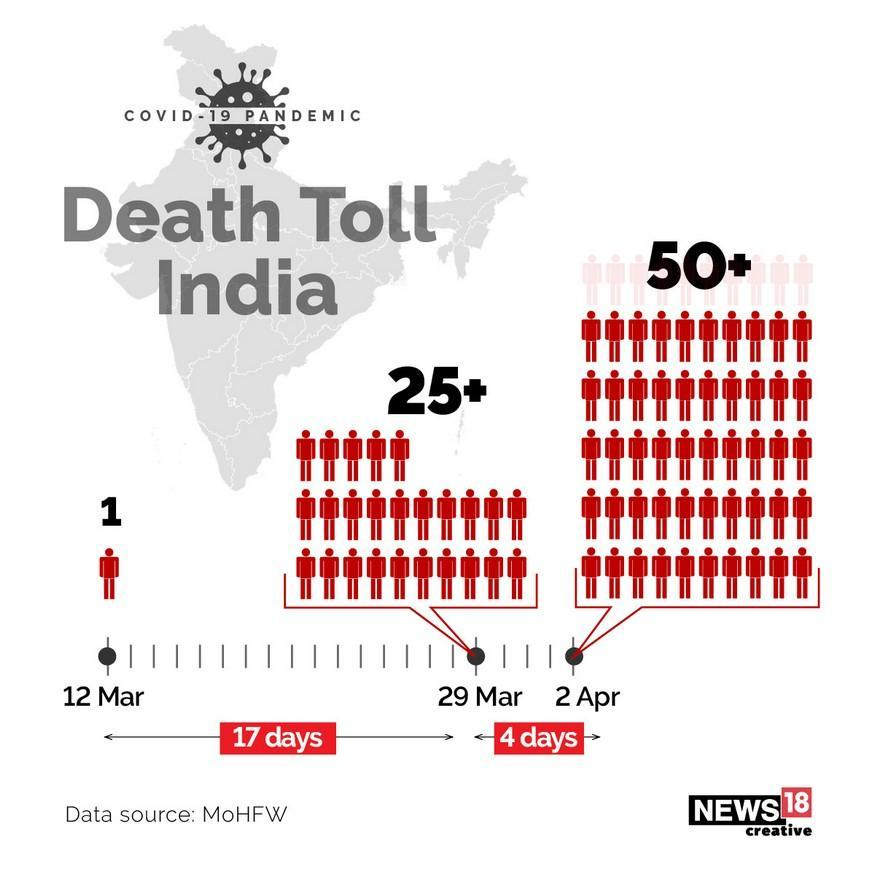What is the difference between 29th march and 12th march?
Answer the question with a short phrase. 17 days How many days are in between 2nd April and 29th March? 4 days How many deaths on 2nd April? 50+ How many deaths on 29 March? 25+ 